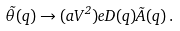Convert formula to latex. <formula><loc_0><loc_0><loc_500><loc_500>\vec { \theta } ( q ) \rightarrow ( a V ^ { 2 } ) e D ( q ) \vec { A } ( q ) \, .</formula> 